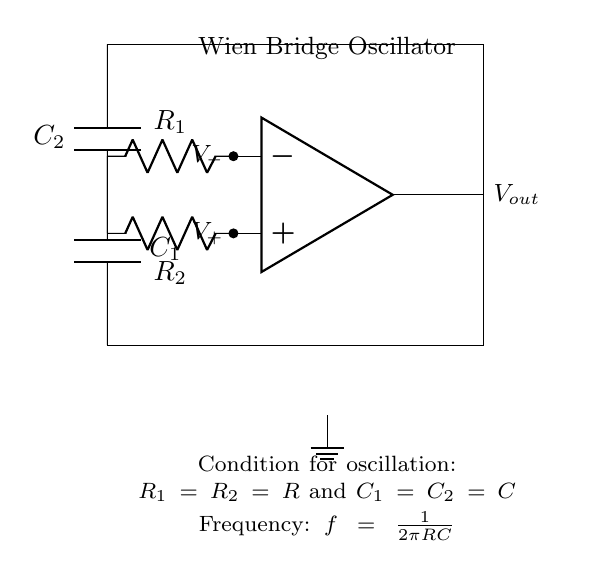What type of oscillator is shown in the circuit? The circuit diagram clearly states the title "Wien Bridge Oscillator" at the top, identifying the type of oscillator used.
Answer: Wien Bridge Oscillator How many resistors are present in the circuit? The circuit diagram shows two resistors labeled R1 and R2 clearly indicated in the layout. Thus, there are a total of two resistors.
Answer: 2 What is the main function of the op-amp in this circuit? The op-amp is used for amplification in the Wien Bridge Oscillator, serving as the active component necessary for generating oscillations.
Answer: Amplification What is the required condition for oscillation in this circuit? The diagram notes that for oscillation to occur, the condition specified is that R1 must equal R2 and C1 must equal C2, which indicates that both resistances and capacitances must be equal.
Answer: R1 = R2 and C1 = C2 What is the relationship between frequency and the components in the circuit? The circuit contains a note stating the frequency formula: f = 1 / (2πRC), indicating that frequency is inversely proportional to the product of resistance and capacitance.
Answer: Frequency: f = 1/(2πRC) At which node does the output voltage appear? The output voltage (Vout) appears at the right side of the op-amp, as indicated by the direction of the connecting wire and the label for Vout.
Answer: Vout located at the right What happens if R1 is not equal to R2 in this circuit? If R1 is not equal to R2, the condition for oscillation is violated, which may prevent the circuit from producing stable oscillations since balance is critical for the Wien Bridge Oscillator to function properly.
Answer: No stable oscillation 